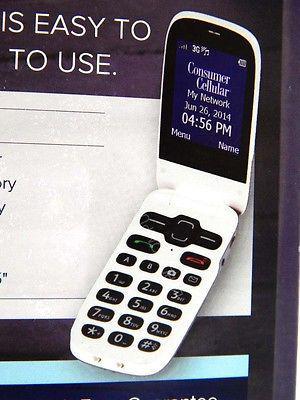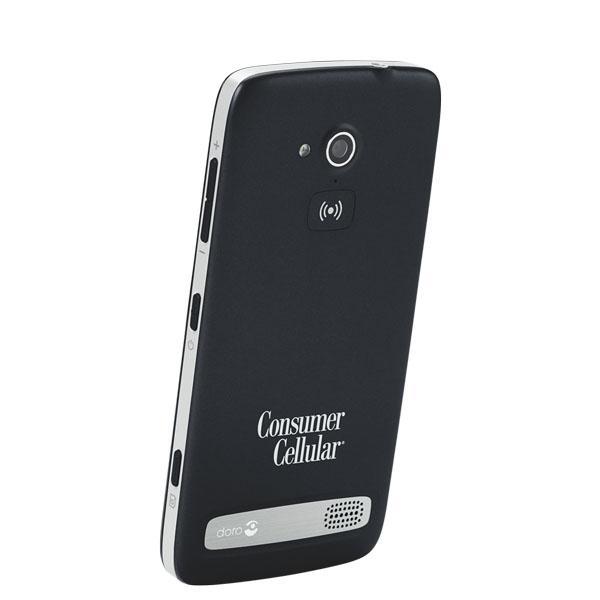The first image is the image on the left, the second image is the image on the right. Assess this claim about the two images: "Left and right images each show an open white flip phone with black buttons, rounded corners, and something displayed on the screen.". Correct or not? Answer yes or no. No. The first image is the image on the left, the second image is the image on the right. Evaluate the accuracy of this statement regarding the images: "The phone in each image is flipped open to reveal the screen.". Is it true? Answer yes or no. No. 